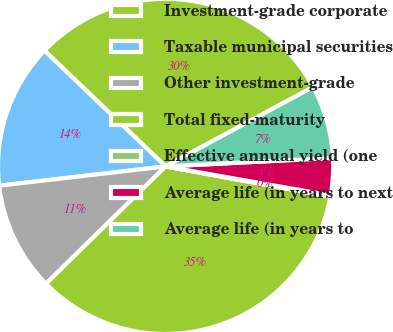Convert chart. <chart><loc_0><loc_0><loc_500><loc_500><pie_chart><fcel>Investment-grade corporate<fcel>Taxable municipal securities<fcel>Other investment-grade<fcel>Total fixed-maturity<fcel>Effective annual yield (one<fcel>Average life (in years to next<fcel>Average life (in years to<nl><fcel>30.0%<fcel>13.98%<fcel>10.51%<fcel>34.76%<fcel>0.12%<fcel>3.58%<fcel>7.05%<nl></chart> 